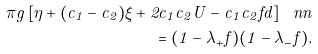Convert formula to latex. <formula><loc_0><loc_0><loc_500><loc_500>\pi g \left [ \eta + ( c _ { 1 } - c _ { 2 } ) \xi + 2 c _ { 1 } c _ { 2 } U - c _ { 1 } c _ { 2 } f d \right ] \ n n \\ = ( 1 - \lambda _ { + } f ) ( 1 - \lambda _ { - } f ) .</formula> 